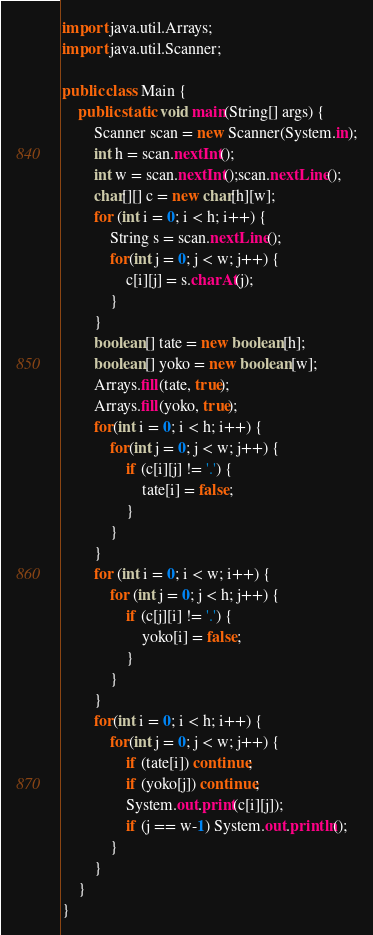<code> <loc_0><loc_0><loc_500><loc_500><_Java_>import java.util.Arrays;
import java.util.Scanner;

public class Main {
    public static void main(String[] args) {
        Scanner scan = new Scanner(System.in);
        int h = scan.nextInt();
        int w = scan.nextInt();scan.nextLine();
        char[][] c = new char[h][w];
        for (int i = 0; i < h; i++) {
            String s = scan.nextLine();
            for(int j = 0; j < w; j++) {
                c[i][j] = s.charAt(j);
            }
        }
        boolean[] tate = new boolean[h];
        boolean[] yoko = new boolean[w];
        Arrays.fill(tate, true);
        Arrays.fill(yoko, true);
        for(int i = 0; i < h; i++) {
            for(int j = 0; j < w; j++) {
                if (c[i][j] != '.') {
                    tate[i] = false;
                }
            }
        }
        for (int i = 0; i < w; i++) {
            for (int j = 0; j < h; j++) {
                if (c[j][i] != '.') {
                    yoko[i] = false;
                }
            }
        }
        for(int i = 0; i < h; i++) {
            for(int j = 0; j < w; j++) {
                if (tate[i]) continue;
                if (yoko[j]) continue;
                System.out.print(c[i][j]);
                if (j == w-1) System.out.println();
            }
        }
    }
}</code> 